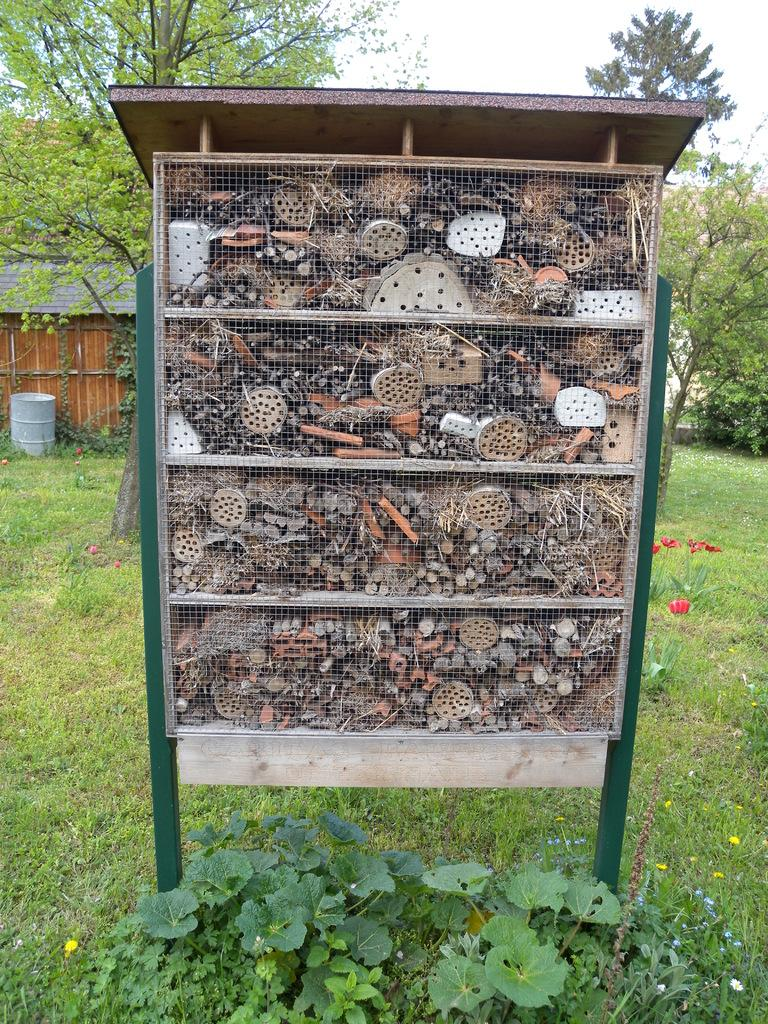What is located in the center of the image? There are objects in the cupboard in the center of the image. What type of natural environment is visible in the background of the image? There is grass, plants, flowers, trees, and the sky visible in the background of the image. What type of structures can be seen in the background of the image? There are houses in the background of the image. What type of zinc can be seen in the image? There is no zinc present in the image. What type of skirt is being worn by the person in the image? There is no person or skirt present in the image. 